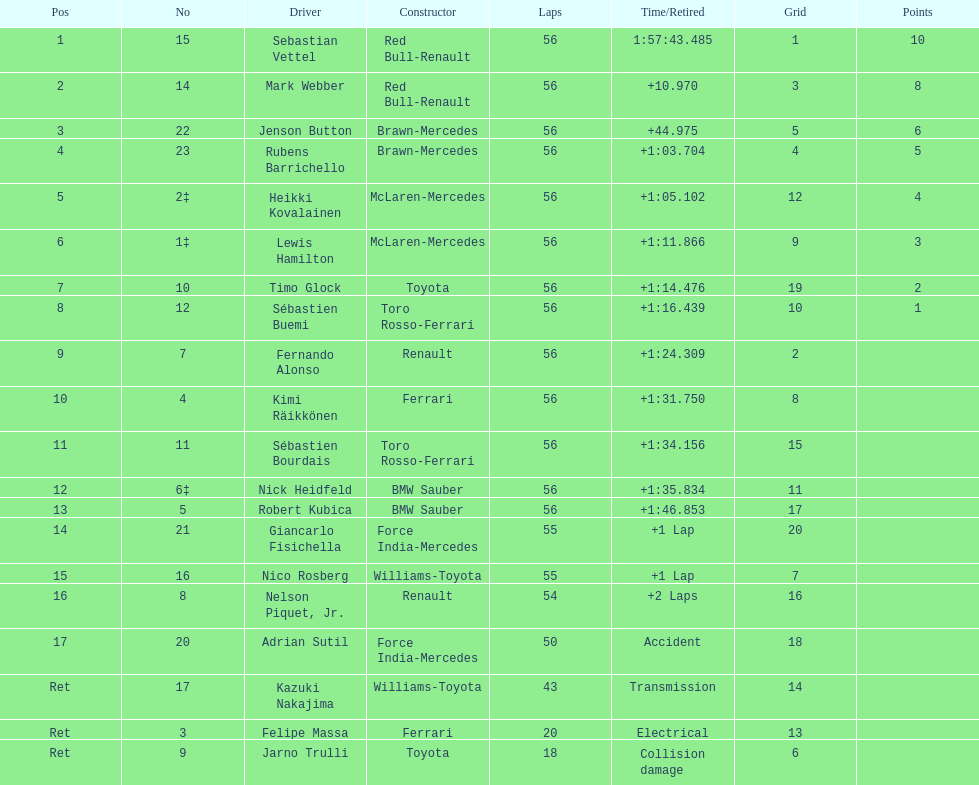Which driver was final on the list? Jarno Trulli. 